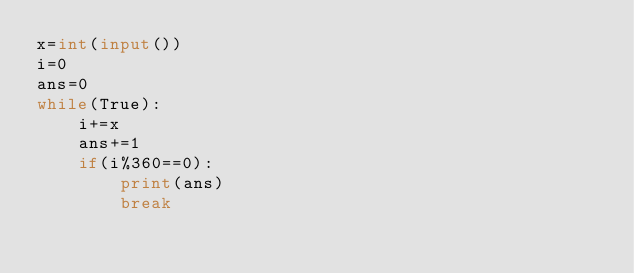<code> <loc_0><loc_0><loc_500><loc_500><_Python_>x=int(input())
i=0
ans=0
while(True):
    i+=x
    ans+=1
    if(i%360==0):
        print(ans)
        break</code> 